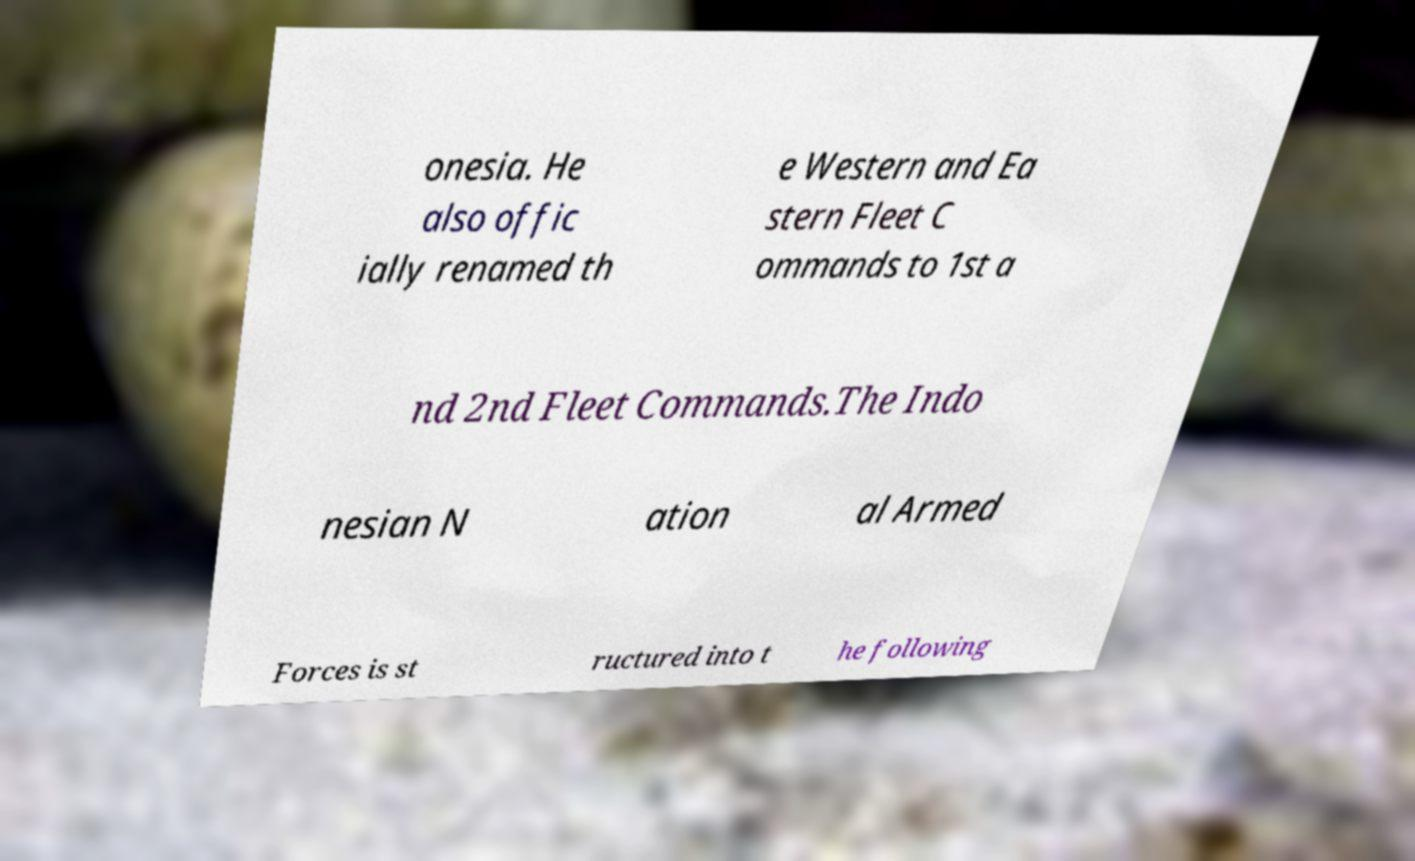Can you read and provide the text displayed in the image?This photo seems to have some interesting text. Can you extract and type it out for me? onesia. He also offic ially renamed th e Western and Ea stern Fleet C ommands to 1st a nd 2nd Fleet Commands.The Indo nesian N ation al Armed Forces is st ructured into t he following 